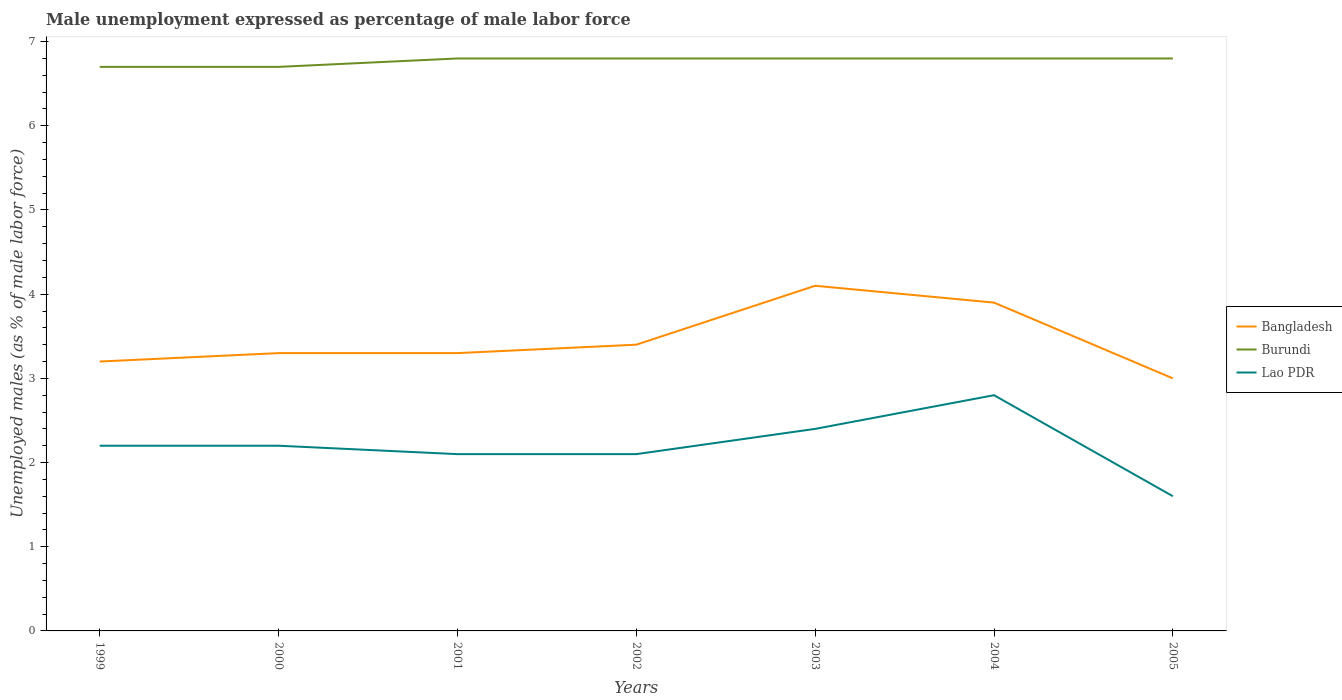Does the line corresponding to Burundi intersect with the line corresponding to Lao PDR?
Offer a terse response. No. Across all years, what is the maximum unemployment in males in in Burundi?
Offer a terse response. 6.7. What is the total unemployment in males in in Bangladesh in the graph?
Offer a terse response. 0.3. What is the difference between the highest and the second highest unemployment in males in in Bangladesh?
Ensure brevity in your answer.  1.1. What is the difference between the highest and the lowest unemployment in males in in Burundi?
Your answer should be very brief. 5. Is the unemployment in males in in Burundi strictly greater than the unemployment in males in in Lao PDR over the years?
Make the answer very short. No. How many years are there in the graph?
Make the answer very short. 7. Are the values on the major ticks of Y-axis written in scientific E-notation?
Ensure brevity in your answer.  No. Does the graph contain any zero values?
Your answer should be very brief. No. Does the graph contain grids?
Offer a very short reply. No. Where does the legend appear in the graph?
Provide a succinct answer. Center right. How many legend labels are there?
Make the answer very short. 3. What is the title of the graph?
Your response must be concise. Male unemployment expressed as percentage of male labor force. What is the label or title of the Y-axis?
Give a very brief answer. Unemployed males (as % of male labor force). What is the Unemployed males (as % of male labor force) of Bangladesh in 1999?
Provide a succinct answer. 3.2. What is the Unemployed males (as % of male labor force) of Burundi in 1999?
Provide a succinct answer. 6.7. What is the Unemployed males (as % of male labor force) in Lao PDR in 1999?
Provide a short and direct response. 2.2. What is the Unemployed males (as % of male labor force) of Bangladesh in 2000?
Give a very brief answer. 3.3. What is the Unemployed males (as % of male labor force) of Burundi in 2000?
Offer a terse response. 6.7. What is the Unemployed males (as % of male labor force) of Lao PDR in 2000?
Give a very brief answer. 2.2. What is the Unemployed males (as % of male labor force) in Bangladesh in 2001?
Provide a short and direct response. 3.3. What is the Unemployed males (as % of male labor force) of Burundi in 2001?
Make the answer very short. 6.8. What is the Unemployed males (as % of male labor force) of Lao PDR in 2001?
Give a very brief answer. 2.1. What is the Unemployed males (as % of male labor force) of Bangladesh in 2002?
Make the answer very short. 3.4. What is the Unemployed males (as % of male labor force) of Burundi in 2002?
Offer a very short reply. 6.8. What is the Unemployed males (as % of male labor force) in Lao PDR in 2002?
Your answer should be compact. 2.1. What is the Unemployed males (as % of male labor force) in Bangladesh in 2003?
Ensure brevity in your answer.  4.1. What is the Unemployed males (as % of male labor force) of Burundi in 2003?
Your response must be concise. 6.8. What is the Unemployed males (as % of male labor force) of Lao PDR in 2003?
Offer a terse response. 2.4. What is the Unemployed males (as % of male labor force) of Bangladesh in 2004?
Your answer should be very brief. 3.9. What is the Unemployed males (as % of male labor force) in Burundi in 2004?
Provide a short and direct response. 6.8. What is the Unemployed males (as % of male labor force) of Lao PDR in 2004?
Your answer should be compact. 2.8. What is the Unemployed males (as % of male labor force) of Burundi in 2005?
Offer a terse response. 6.8. What is the Unemployed males (as % of male labor force) in Lao PDR in 2005?
Provide a succinct answer. 1.6. Across all years, what is the maximum Unemployed males (as % of male labor force) in Bangladesh?
Offer a terse response. 4.1. Across all years, what is the maximum Unemployed males (as % of male labor force) of Burundi?
Give a very brief answer. 6.8. Across all years, what is the maximum Unemployed males (as % of male labor force) in Lao PDR?
Your response must be concise. 2.8. Across all years, what is the minimum Unemployed males (as % of male labor force) of Burundi?
Make the answer very short. 6.7. Across all years, what is the minimum Unemployed males (as % of male labor force) in Lao PDR?
Your response must be concise. 1.6. What is the total Unemployed males (as % of male labor force) in Bangladesh in the graph?
Your response must be concise. 24.2. What is the total Unemployed males (as % of male labor force) in Burundi in the graph?
Your answer should be very brief. 47.4. What is the difference between the Unemployed males (as % of male labor force) of Bangladesh in 1999 and that in 2000?
Ensure brevity in your answer.  -0.1. What is the difference between the Unemployed males (as % of male labor force) of Bangladesh in 1999 and that in 2001?
Ensure brevity in your answer.  -0.1. What is the difference between the Unemployed males (as % of male labor force) of Lao PDR in 1999 and that in 2001?
Keep it short and to the point. 0.1. What is the difference between the Unemployed males (as % of male labor force) of Bangladesh in 1999 and that in 2002?
Your response must be concise. -0.2. What is the difference between the Unemployed males (as % of male labor force) in Burundi in 1999 and that in 2002?
Your response must be concise. -0.1. What is the difference between the Unemployed males (as % of male labor force) in Lao PDR in 1999 and that in 2002?
Give a very brief answer. 0.1. What is the difference between the Unemployed males (as % of male labor force) of Lao PDR in 1999 and that in 2003?
Keep it short and to the point. -0.2. What is the difference between the Unemployed males (as % of male labor force) in Burundi in 1999 and that in 2005?
Offer a terse response. -0.1. What is the difference between the Unemployed males (as % of male labor force) in Bangladesh in 2000 and that in 2001?
Keep it short and to the point. 0. What is the difference between the Unemployed males (as % of male labor force) in Burundi in 2000 and that in 2001?
Make the answer very short. -0.1. What is the difference between the Unemployed males (as % of male labor force) of Lao PDR in 2000 and that in 2001?
Give a very brief answer. 0.1. What is the difference between the Unemployed males (as % of male labor force) of Lao PDR in 2000 and that in 2002?
Offer a terse response. 0.1. What is the difference between the Unemployed males (as % of male labor force) in Burundi in 2000 and that in 2003?
Keep it short and to the point. -0.1. What is the difference between the Unemployed males (as % of male labor force) in Lao PDR in 2000 and that in 2003?
Give a very brief answer. -0.2. What is the difference between the Unemployed males (as % of male labor force) in Burundi in 2000 and that in 2004?
Give a very brief answer. -0.1. What is the difference between the Unemployed males (as % of male labor force) of Bangladesh in 2000 and that in 2005?
Your answer should be compact. 0.3. What is the difference between the Unemployed males (as % of male labor force) of Burundi in 2000 and that in 2005?
Your answer should be very brief. -0.1. What is the difference between the Unemployed males (as % of male labor force) in Lao PDR in 2000 and that in 2005?
Provide a short and direct response. 0.6. What is the difference between the Unemployed males (as % of male labor force) in Bangladesh in 2001 and that in 2002?
Your response must be concise. -0.1. What is the difference between the Unemployed males (as % of male labor force) in Burundi in 2001 and that in 2002?
Ensure brevity in your answer.  0. What is the difference between the Unemployed males (as % of male labor force) of Lao PDR in 2001 and that in 2002?
Offer a terse response. 0. What is the difference between the Unemployed males (as % of male labor force) of Lao PDR in 2001 and that in 2003?
Make the answer very short. -0.3. What is the difference between the Unemployed males (as % of male labor force) in Bangladesh in 2001 and that in 2004?
Offer a very short reply. -0.6. What is the difference between the Unemployed males (as % of male labor force) in Bangladesh in 2001 and that in 2005?
Provide a short and direct response. 0.3. What is the difference between the Unemployed males (as % of male labor force) in Lao PDR in 2001 and that in 2005?
Ensure brevity in your answer.  0.5. What is the difference between the Unemployed males (as % of male labor force) in Bangladesh in 2002 and that in 2003?
Your response must be concise. -0.7. What is the difference between the Unemployed males (as % of male labor force) in Lao PDR in 2002 and that in 2004?
Give a very brief answer. -0.7. What is the difference between the Unemployed males (as % of male labor force) of Bangladesh in 2002 and that in 2005?
Offer a terse response. 0.4. What is the difference between the Unemployed males (as % of male labor force) in Bangladesh in 2003 and that in 2005?
Offer a terse response. 1.1. What is the difference between the Unemployed males (as % of male labor force) of Bangladesh in 2004 and that in 2005?
Your answer should be very brief. 0.9. What is the difference between the Unemployed males (as % of male labor force) of Burundi in 2004 and that in 2005?
Your answer should be very brief. 0. What is the difference between the Unemployed males (as % of male labor force) in Bangladesh in 1999 and the Unemployed males (as % of male labor force) in Burundi in 2000?
Ensure brevity in your answer.  -3.5. What is the difference between the Unemployed males (as % of male labor force) in Burundi in 1999 and the Unemployed males (as % of male labor force) in Lao PDR in 2000?
Your response must be concise. 4.5. What is the difference between the Unemployed males (as % of male labor force) in Bangladesh in 1999 and the Unemployed males (as % of male labor force) in Burundi in 2002?
Your answer should be compact. -3.6. What is the difference between the Unemployed males (as % of male labor force) in Bangladesh in 1999 and the Unemployed males (as % of male labor force) in Lao PDR in 2002?
Give a very brief answer. 1.1. What is the difference between the Unemployed males (as % of male labor force) in Bangladesh in 1999 and the Unemployed males (as % of male labor force) in Burundi in 2003?
Your answer should be very brief. -3.6. What is the difference between the Unemployed males (as % of male labor force) in Bangladesh in 1999 and the Unemployed males (as % of male labor force) in Lao PDR in 2003?
Your response must be concise. 0.8. What is the difference between the Unemployed males (as % of male labor force) of Burundi in 1999 and the Unemployed males (as % of male labor force) of Lao PDR in 2003?
Provide a succinct answer. 4.3. What is the difference between the Unemployed males (as % of male labor force) in Bangladesh in 1999 and the Unemployed males (as % of male labor force) in Burundi in 2004?
Offer a terse response. -3.6. What is the difference between the Unemployed males (as % of male labor force) of Bangladesh in 1999 and the Unemployed males (as % of male labor force) of Lao PDR in 2004?
Offer a terse response. 0.4. What is the difference between the Unemployed males (as % of male labor force) of Burundi in 1999 and the Unemployed males (as % of male labor force) of Lao PDR in 2004?
Ensure brevity in your answer.  3.9. What is the difference between the Unemployed males (as % of male labor force) of Bangladesh in 1999 and the Unemployed males (as % of male labor force) of Lao PDR in 2005?
Provide a succinct answer. 1.6. What is the difference between the Unemployed males (as % of male labor force) in Bangladesh in 2000 and the Unemployed males (as % of male labor force) in Burundi in 2001?
Your response must be concise. -3.5. What is the difference between the Unemployed males (as % of male labor force) of Burundi in 2000 and the Unemployed males (as % of male labor force) of Lao PDR in 2001?
Your answer should be compact. 4.6. What is the difference between the Unemployed males (as % of male labor force) of Bangladesh in 2000 and the Unemployed males (as % of male labor force) of Burundi in 2002?
Make the answer very short. -3.5. What is the difference between the Unemployed males (as % of male labor force) of Bangladesh in 2000 and the Unemployed males (as % of male labor force) of Lao PDR in 2002?
Offer a terse response. 1.2. What is the difference between the Unemployed males (as % of male labor force) of Bangladesh in 2000 and the Unemployed males (as % of male labor force) of Burundi in 2004?
Your response must be concise. -3.5. What is the difference between the Unemployed males (as % of male labor force) of Bangladesh in 2000 and the Unemployed males (as % of male labor force) of Lao PDR in 2004?
Offer a terse response. 0.5. What is the difference between the Unemployed males (as % of male labor force) of Bangladesh in 2000 and the Unemployed males (as % of male labor force) of Burundi in 2005?
Your answer should be very brief. -3.5. What is the difference between the Unemployed males (as % of male labor force) in Burundi in 2000 and the Unemployed males (as % of male labor force) in Lao PDR in 2005?
Provide a succinct answer. 5.1. What is the difference between the Unemployed males (as % of male labor force) in Bangladesh in 2001 and the Unemployed males (as % of male labor force) in Burundi in 2003?
Ensure brevity in your answer.  -3.5. What is the difference between the Unemployed males (as % of male labor force) in Bangladesh in 2001 and the Unemployed males (as % of male labor force) in Lao PDR in 2003?
Your answer should be very brief. 0.9. What is the difference between the Unemployed males (as % of male labor force) in Burundi in 2001 and the Unemployed males (as % of male labor force) in Lao PDR in 2003?
Offer a very short reply. 4.4. What is the difference between the Unemployed males (as % of male labor force) of Bangladesh in 2001 and the Unemployed males (as % of male labor force) of Burundi in 2004?
Ensure brevity in your answer.  -3.5. What is the difference between the Unemployed males (as % of male labor force) in Bangladesh in 2001 and the Unemployed males (as % of male labor force) in Lao PDR in 2004?
Give a very brief answer. 0.5. What is the difference between the Unemployed males (as % of male labor force) in Burundi in 2001 and the Unemployed males (as % of male labor force) in Lao PDR in 2004?
Keep it short and to the point. 4. What is the difference between the Unemployed males (as % of male labor force) in Bangladesh in 2001 and the Unemployed males (as % of male labor force) in Burundi in 2005?
Provide a succinct answer. -3.5. What is the difference between the Unemployed males (as % of male labor force) of Bangladesh in 2001 and the Unemployed males (as % of male labor force) of Lao PDR in 2005?
Make the answer very short. 1.7. What is the difference between the Unemployed males (as % of male labor force) in Burundi in 2001 and the Unemployed males (as % of male labor force) in Lao PDR in 2005?
Provide a short and direct response. 5.2. What is the difference between the Unemployed males (as % of male labor force) in Bangladesh in 2002 and the Unemployed males (as % of male labor force) in Lao PDR in 2003?
Your answer should be very brief. 1. What is the difference between the Unemployed males (as % of male labor force) in Burundi in 2002 and the Unemployed males (as % of male labor force) in Lao PDR in 2003?
Ensure brevity in your answer.  4.4. What is the difference between the Unemployed males (as % of male labor force) in Bangladesh in 2002 and the Unemployed males (as % of male labor force) in Burundi in 2004?
Keep it short and to the point. -3.4. What is the difference between the Unemployed males (as % of male labor force) of Burundi in 2002 and the Unemployed males (as % of male labor force) of Lao PDR in 2004?
Your answer should be very brief. 4. What is the difference between the Unemployed males (as % of male labor force) in Bangladesh in 2002 and the Unemployed males (as % of male labor force) in Burundi in 2005?
Make the answer very short. -3.4. What is the difference between the Unemployed males (as % of male labor force) of Bangladesh in 2002 and the Unemployed males (as % of male labor force) of Lao PDR in 2005?
Make the answer very short. 1.8. What is the difference between the Unemployed males (as % of male labor force) of Bangladesh in 2003 and the Unemployed males (as % of male labor force) of Lao PDR in 2004?
Your answer should be very brief. 1.3. What is the difference between the Unemployed males (as % of male labor force) of Bangladesh in 2003 and the Unemployed males (as % of male labor force) of Burundi in 2005?
Your answer should be compact. -2.7. What is the difference between the Unemployed males (as % of male labor force) of Burundi in 2003 and the Unemployed males (as % of male labor force) of Lao PDR in 2005?
Ensure brevity in your answer.  5.2. What is the difference between the Unemployed males (as % of male labor force) in Bangladesh in 2004 and the Unemployed males (as % of male labor force) in Lao PDR in 2005?
Provide a short and direct response. 2.3. What is the average Unemployed males (as % of male labor force) of Bangladesh per year?
Your answer should be compact. 3.46. What is the average Unemployed males (as % of male labor force) in Burundi per year?
Your answer should be compact. 6.77. What is the average Unemployed males (as % of male labor force) of Lao PDR per year?
Your response must be concise. 2.2. In the year 1999, what is the difference between the Unemployed males (as % of male labor force) in Burundi and Unemployed males (as % of male labor force) in Lao PDR?
Your answer should be compact. 4.5. In the year 2000, what is the difference between the Unemployed males (as % of male labor force) of Bangladesh and Unemployed males (as % of male labor force) of Burundi?
Provide a succinct answer. -3.4. In the year 2001, what is the difference between the Unemployed males (as % of male labor force) in Bangladesh and Unemployed males (as % of male labor force) in Burundi?
Your answer should be very brief. -3.5. In the year 2002, what is the difference between the Unemployed males (as % of male labor force) in Bangladesh and Unemployed males (as % of male labor force) in Burundi?
Your response must be concise. -3.4. In the year 2002, what is the difference between the Unemployed males (as % of male labor force) in Burundi and Unemployed males (as % of male labor force) in Lao PDR?
Your answer should be compact. 4.7. In the year 2003, what is the difference between the Unemployed males (as % of male labor force) in Burundi and Unemployed males (as % of male labor force) in Lao PDR?
Offer a terse response. 4.4. In the year 2004, what is the difference between the Unemployed males (as % of male labor force) in Bangladesh and Unemployed males (as % of male labor force) in Burundi?
Offer a very short reply. -2.9. In the year 2004, what is the difference between the Unemployed males (as % of male labor force) of Bangladesh and Unemployed males (as % of male labor force) of Lao PDR?
Keep it short and to the point. 1.1. In the year 2004, what is the difference between the Unemployed males (as % of male labor force) of Burundi and Unemployed males (as % of male labor force) of Lao PDR?
Provide a short and direct response. 4. In the year 2005, what is the difference between the Unemployed males (as % of male labor force) in Bangladesh and Unemployed males (as % of male labor force) in Burundi?
Your answer should be very brief. -3.8. In the year 2005, what is the difference between the Unemployed males (as % of male labor force) in Bangladesh and Unemployed males (as % of male labor force) in Lao PDR?
Provide a short and direct response. 1.4. What is the ratio of the Unemployed males (as % of male labor force) of Bangladesh in 1999 to that in 2000?
Offer a terse response. 0.97. What is the ratio of the Unemployed males (as % of male labor force) of Burundi in 1999 to that in 2000?
Give a very brief answer. 1. What is the ratio of the Unemployed males (as % of male labor force) of Bangladesh in 1999 to that in 2001?
Your answer should be very brief. 0.97. What is the ratio of the Unemployed males (as % of male labor force) of Burundi in 1999 to that in 2001?
Offer a very short reply. 0.99. What is the ratio of the Unemployed males (as % of male labor force) of Lao PDR in 1999 to that in 2001?
Your answer should be very brief. 1.05. What is the ratio of the Unemployed males (as % of male labor force) in Lao PDR in 1999 to that in 2002?
Keep it short and to the point. 1.05. What is the ratio of the Unemployed males (as % of male labor force) in Bangladesh in 1999 to that in 2003?
Keep it short and to the point. 0.78. What is the ratio of the Unemployed males (as % of male labor force) of Burundi in 1999 to that in 2003?
Your answer should be very brief. 0.99. What is the ratio of the Unemployed males (as % of male labor force) of Lao PDR in 1999 to that in 2003?
Provide a succinct answer. 0.92. What is the ratio of the Unemployed males (as % of male labor force) in Bangladesh in 1999 to that in 2004?
Keep it short and to the point. 0.82. What is the ratio of the Unemployed males (as % of male labor force) of Lao PDR in 1999 to that in 2004?
Ensure brevity in your answer.  0.79. What is the ratio of the Unemployed males (as % of male labor force) of Bangladesh in 1999 to that in 2005?
Provide a succinct answer. 1.07. What is the ratio of the Unemployed males (as % of male labor force) in Lao PDR in 1999 to that in 2005?
Provide a succinct answer. 1.38. What is the ratio of the Unemployed males (as % of male labor force) of Lao PDR in 2000 to that in 2001?
Make the answer very short. 1.05. What is the ratio of the Unemployed males (as % of male labor force) of Bangladesh in 2000 to that in 2002?
Offer a terse response. 0.97. What is the ratio of the Unemployed males (as % of male labor force) in Lao PDR in 2000 to that in 2002?
Your answer should be very brief. 1.05. What is the ratio of the Unemployed males (as % of male labor force) of Bangladesh in 2000 to that in 2003?
Your answer should be very brief. 0.8. What is the ratio of the Unemployed males (as % of male labor force) in Burundi in 2000 to that in 2003?
Your answer should be compact. 0.99. What is the ratio of the Unemployed males (as % of male labor force) in Bangladesh in 2000 to that in 2004?
Keep it short and to the point. 0.85. What is the ratio of the Unemployed males (as % of male labor force) of Lao PDR in 2000 to that in 2004?
Give a very brief answer. 0.79. What is the ratio of the Unemployed males (as % of male labor force) of Bangladesh in 2000 to that in 2005?
Offer a very short reply. 1.1. What is the ratio of the Unemployed males (as % of male labor force) of Burundi in 2000 to that in 2005?
Offer a terse response. 0.99. What is the ratio of the Unemployed males (as % of male labor force) in Lao PDR in 2000 to that in 2005?
Provide a succinct answer. 1.38. What is the ratio of the Unemployed males (as % of male labor force) of Bangladesh in 2001 to that in 2002?
Ensure brevity in your answer.  0.97. What is the ratio of the Unemployed males (as % of male labor force) in Lao PDR in 2001 to that in 2002?
Your response must be concise. 1. What is the ratio of the Unemployed males (as % of male labor force) in Bangladesh in 2001 to that in 2003?
Provide a short and direct response. 0.8. What is the ratio of the Unemployed males (as % of male labor force) of Burundi in 2001 to that in 2003?
Provide a short and direct response. 1. What is the ratio of the Unemployed males (as % of male labor force) of Lao PDR in 2001 to that in 2003?
Offer a very short reply. 0.88. What is the ratio of the Unemployed males (as % of male labor force) in Bangladesh in 2001 to that in 2004?
Make the answer very short. 0.85. What is the ratio of the Unemployed males (as % of male labor force) of Burundi in 2001 to that in 2004?
Your answer should be compact. 1. What is the ratio of the Unemployed males (as % of male labor force) of Lao PDR in 2001 to that in 2004?
Offer a terse response. 0.75. What is the ratio of the Unemployed males (as % of male labor force) of Bangladesh in 2001 to that in 2005?
Make the answer very short. 1.1. What is the ratio of the Unemployed males (as % of male labor force) in Burundi in 2001 to that in 2005?
Offer a very short reply. 1. What is the ratio of the Unemployed males (as % of male labor force) of Lao PDR in 2001 to that in 2005?
Give a very brief answer. 1.31. What is the ratio of the Unemployed males (as % of male labor force) in Bangladesh in 2002 to that in 2003?
Provide a short and direct response. 0.83. What is the ratio of the Unemployed males (as % of male labor force) of Lao PDR in 2002 to that in 2003?
Your answer should be compact. 0.88. What is the ratio of the Unemployed males (as % of male labor force) of Bangladesh in 2002 to that in 2004?
Offer a very short reply. 0.87. What is the ratio of the Unemployed males (as % of male labor force) of Burundi in 2002 to that in 2004?
Your answer should be compact. 1. What is the ratio of the Unemployed males (as % of male labor force) in Lao PDR in 2002 to that in 2004?
Make the answer very short. 0.75. What is the ratio of the Unemployed males (as % of male labor force) in Bangladesh in 2002 to that in 2005?
Offer a very short reply. 1.13. What is the ratio of the Unemployed males (as % of male labor force) in Lao PDR in 2002 to that in 2005?
Provide a short and direct response. 1.31. What is the ratio of the Unemployed males (as % of male labor force) in Bangladesh in 2003 to that in 2004?
Your response must be concise. 1.05. What is the ratio of the Unemployed males (as % of male labor force) of Burundi in 2003 to that in 2004?
Ensure brevity in your answer.  1. What is the ratio of the Unemployed males (as % of male labor force) in Lao PDR in 2003 to that in 2004?
Your response must be concise. 0.86. What is the ratio of the Unemployed males (as % of male labor force) in Bangladesh in 2003 to that in 2005?
Make the answer very short. 1.37. What is the ratio of the Unemployed males (as % of male labor force) in Burundi in 2003 to that in 2005?
Your answer should be compact. 1. What is the ratio of the Unemployed males (as % of male labor force) of Lao PDR in 2003 to that in 2005?
Provide a short and direct response. 1.5. What is the ratio of the Unemployed males (as % of male labor force) in Burundi in 2004 to that in 2005?
Provide a short and direct response. 1. What is the ratio of the Unemployed males (as % of male labor force) in Lao PDR in 2004 to that in 2005?
Provide a succinct answer. 1.75. What is the difference between the highest and the second highest Unemployed males (as % of male labor force) of Burundi?
Offer a very short reply. 0. What is the difference between the highest and the lowest Unemployed males (as % of male labor force) in Bangladesh?
Provide a succinct answer. 1.1. 